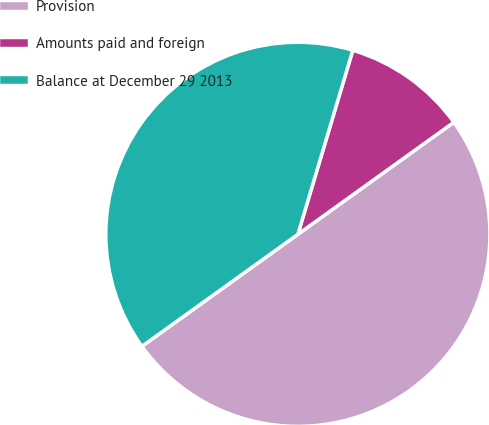<chart> <loc_0><loc_0><loc_500><loc_500><pie_chart><fcel>Provision<fcel>Amounts paid and foreign<fcel>Balance at December 29 2013<nl><fcel>50.0%<fcel>10.47%<fcel>39.53%<nl></chart> 